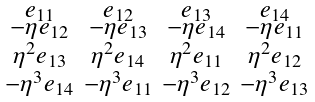<formula> <loc_0><loc_0><loc_500><loc_500>\begin{smallmatrix} e _ { 1 1 } & e _ { 1 2 } & e _ { 1 3 } & e _ { 1 4 } \\ - \eta e _ { 1 2 } & - \eta e _ { 1 3 } & - \eta e _ { 1 4 } & - \eta e _ { 1 1 } \\ \eta ^ { 2 } e _ { 1 3 } & \eta ^ { 2 } e _ { 1 4 } & \eta ^ { 2 } e _ { 1 1 } & \eta ^ { 2 } e _ { 1 2 } \\ - \eta ^ { 3 } e _ { 1 4 } & - \eta ^ { 3 } e _ { 1 1 } & - \eta ^ { 3 } e _ { 1 2 } & - \eta ^ { 3 } e _ { 1 3 } \end{smallmatrix}</formula> 